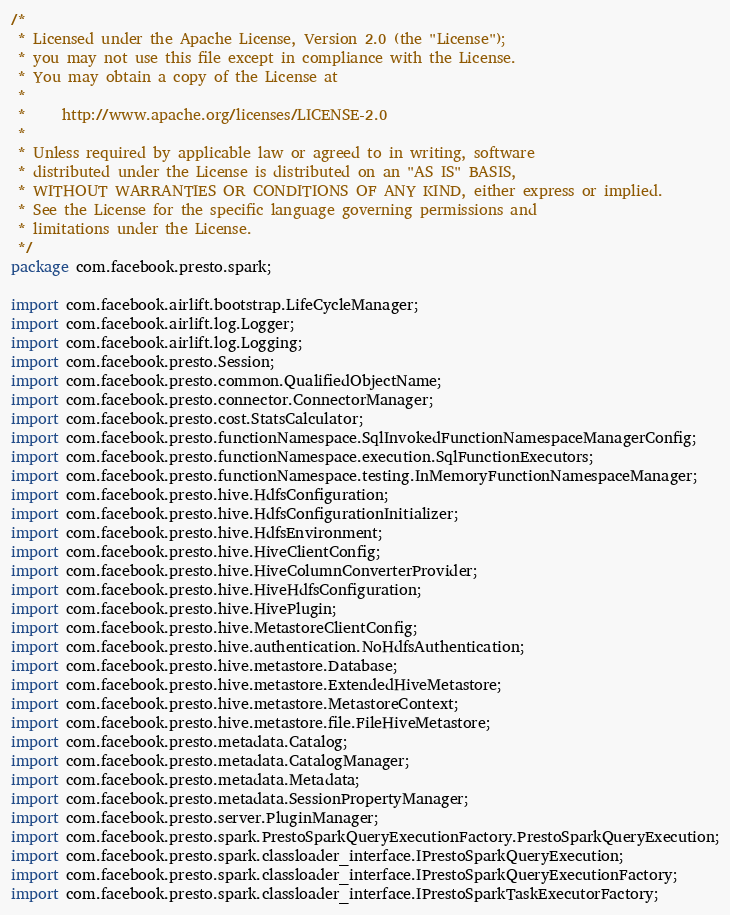<code> <loc_0><loc_0><loc_500><loc_500><_Java_>/*
 * Licensed under the Apache License, Version 2.0 (the "License");
 * you may not use this file except in compliance with the License.
 * You may obtain a copy of the License at
 *
 *     http://www.apache.org/licenses/LICENSE-2.0
 *
 * Unless required by applicable law or agreed to in writing, software
 * distributed under the License is distributed on an "AS IS" BASIS,
 * WITHOUT WARRANTIES OR CONDITIONS OF ANY KIND, either express or implied.
 * See the License for the specific language governing permissions and
 * limitations under the License.
 */
package com.facebook.presto.spark;

import com.facebook.airlift.bootstrap.LifeCycleManager;
import com.facebook.airlift.log.Logger;
import com.facebook.airlift.log.Logging;
import com.facebook.presto.Session;
import com.facebook.presto.common.QualifiedObjectName;
import com.facebook.presto.connector.ConnectorManager;
import com.facebook.presto.cost.StatsCalculator;
import com.facebook.presto.functionNamespace.SqlInvokedFunctionNamespaceManagerConfig;
import com.facebook.presto.functionNamespace.execution.SqlFunctionExecutors;
import com.facebook.presto.functionNamespace.testing.InMemoryFunctionNamespaceManager;
import com.facebook.presto.hive.HdfsConfiguration;
import com.facebook.presto.hive.HdfsConfigurationInitializer;
import com.facebook.presto.hive.HdfsEnvironment;
import com.facebook.presto.hive.HiveClientConfig;
import com.facebook.presto.hive.HiveColumnConverterProvider;
import com.facebook.presto.hive.HiveHdfsConfiguration;
import com.facebook.presto.hive.HivePlugin;
import com.facebook.presto.hive.MetastoreClientConfig;
import com.facebook.presto.hive.authentication.NoHdfsAuthentication;
import com.facebook.presto.hive.metastore.Database;
import com.facebook.presto.hive.metastore.ExtendedHiveMetastore;
import com.facebook.presto.hive.metastore.MetastoreContext;
import com.facebook.presto.hive.metastore.file.FileHiveMetastore;
import com.facebook.presto.metadata.Catalog;
import com.facebook.presto.metadata.CatalogManager;
import com.facebook.presto.metadata.Metadata;
import com.facebook.presto.metadata.SessionPropertyManager;
import com.facebook.presto.server.PluginManager;
import com.facebook.presto.spark.PrestoSparkQueryExecutionFactory.PrestoSparkQueryExecution;
import com.facebook.presto.spark.classloader_interface.IPrestoSparkQueryExecution;
import com.facebook.presto.spark.classloader_interface.IPrestoSparkQueryExecutionFactory;
import com.facebook.presto.spark.classloader_interface.IPrestoSparkTaskExecutorFactory;</code> 